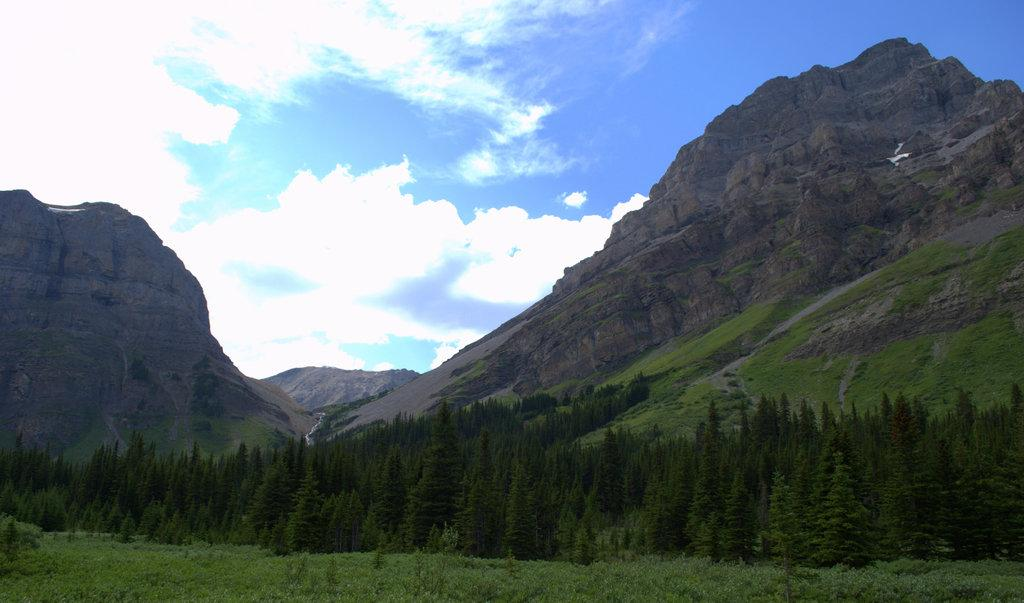What type of vegetation is present in the image? There are many trees and plants in the image. Where are the mountains located in the image? There are mountains on both the left and right sides of the image. What is the color of the grass at the bottom of the image? The grass at the bottom of the image is green. What can be seen in the sky at the top of the image? There are clouds in the sky at the top of the image. How many questions are tied in a knot at the top of the mountains in the image? There are no questions or knots present in the image; it features trees, plants, mountains, grass, and clouds. 